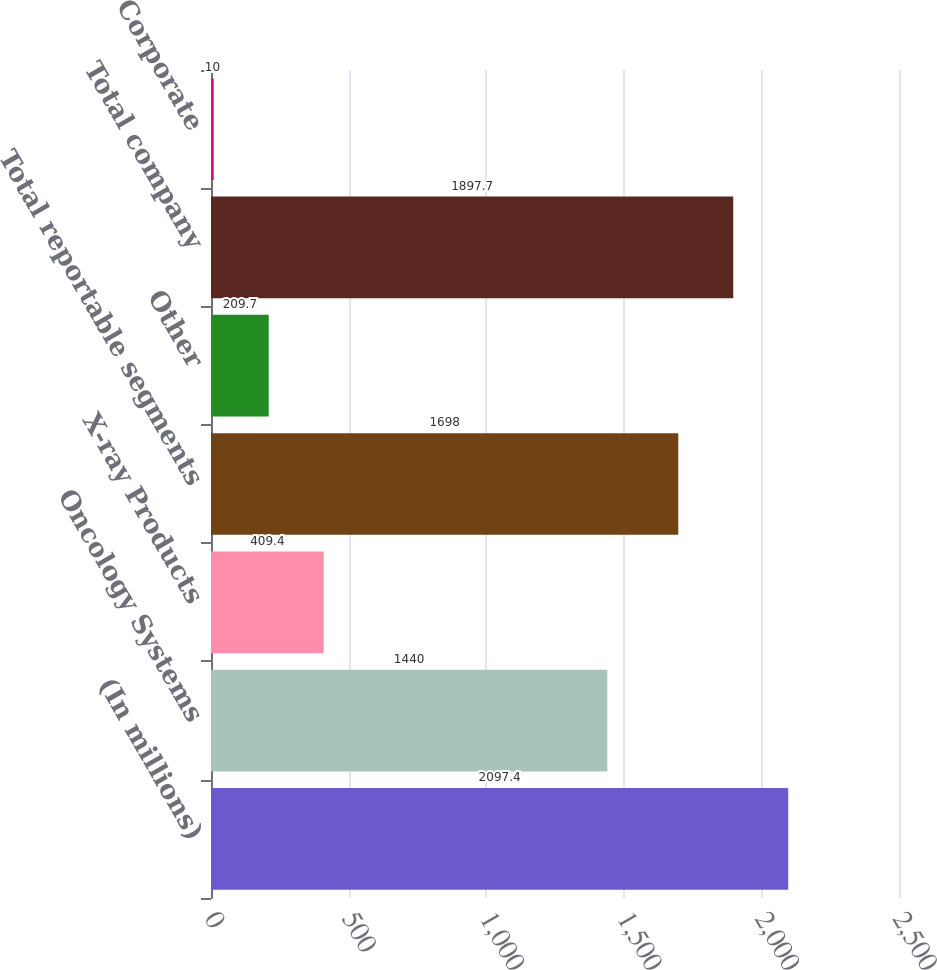Convert chart. <chart><loc_0><loc_0><loc_500><loc_500><bar_chart><fcel>(In millions)<fcel>Oncology Systems<fcel>X-ray Products<fcel>Total reportable segments<fcel>Other<fcel>Total company<fcel>Corporate<nl><fcel>2097.4<fcel>1440<fcel>409.4<fcel>1698<fcel>209.7<fcel>1897.7<fcel>10<nl></chart> 